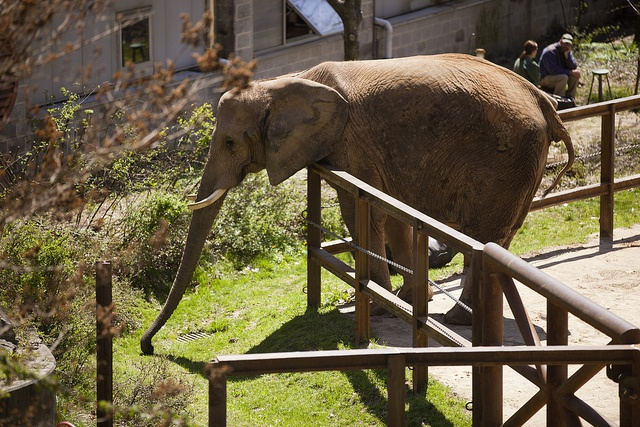Describe the objects in this image and their specific colors. I can see elephant in gray, black, maroon, and tan tones, people in gray, black, and maroon tones, and people in gray, black, and maroon tones in this image. 